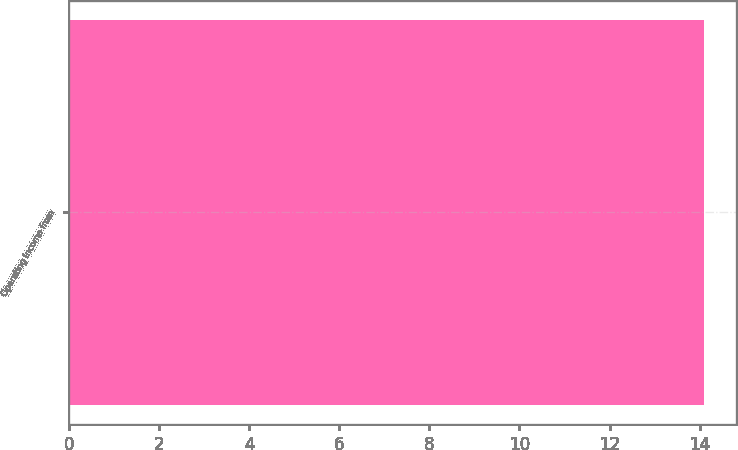Convert chart. <chart><loc_0><loc_0><loc_500><loc_500><bar_chart><fcel>Operating income from<nl><fcel>14.1<nl></chart> 